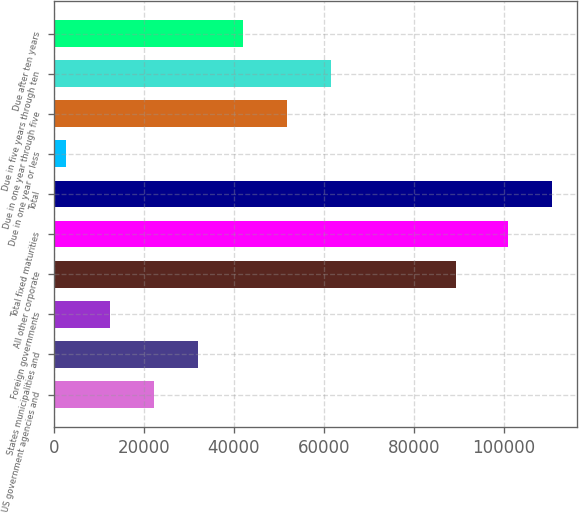Convert chart to OTSL. <chart><loc_0><loc_0><loc_500><loc_500><bar_chart><fcel>US government agencies and<fcel>States municipalities and<fcel>Foreign governments<fcel>All other corporate<fcel>Total fixed maturities<fcel>Total<fcel>Due in one year or less<fcel>Due in one year through five<fcel>Due in five years through ten<fcel>Due after ten years<nl><fcel>22303.2<fcel>32128.3<fcel>12478.1<fcel>89378<fcel>100904<fcel>110729<fcel>2653<fcel>51778.5<fcel>61603.6<fcel>41953.4<nl></chart> 